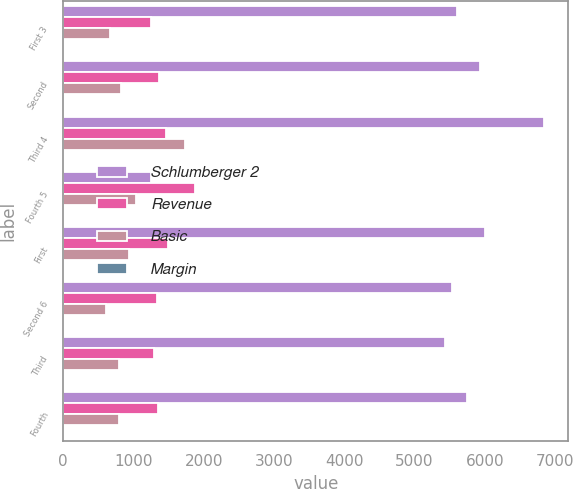Convert chart to OTSL. <chart><loc_0><loc_0><loc_500><loc_500><stacked_bar_chart><ecel><fcel>First 3<fcel>Second<fcel>Third 4<fcel>Fourth 5<fcel>First<fcel>Second 6<fcel>Third<fcel>Fourth<nl><fcel>Schlumberger 2<fcel>5598<fcel>5937<fcel>6845<fcel>1256<fcel>6000<fcel>5528<fcel>5430<fcel>5744<nl><fcel>Revenue<fcel>1256<fcel>1361<fcel>1461<fcel>1870<fcel>1490<fcel>1333<fcel>1286<fcel>1346<nl><fcel>Basic<fcel>672<fcel>818<fcel>1734<fcel>1043<fcel>938<fcel>613<fcel>787<fcel>795<nl><fcel>Margin<fcel>0.56<fcel>0.69<fcel>1.39<fcel>0.76<fcel>0.78<fcel>0.51<fcel>0.66<fcel>0.66<nl></chart> 